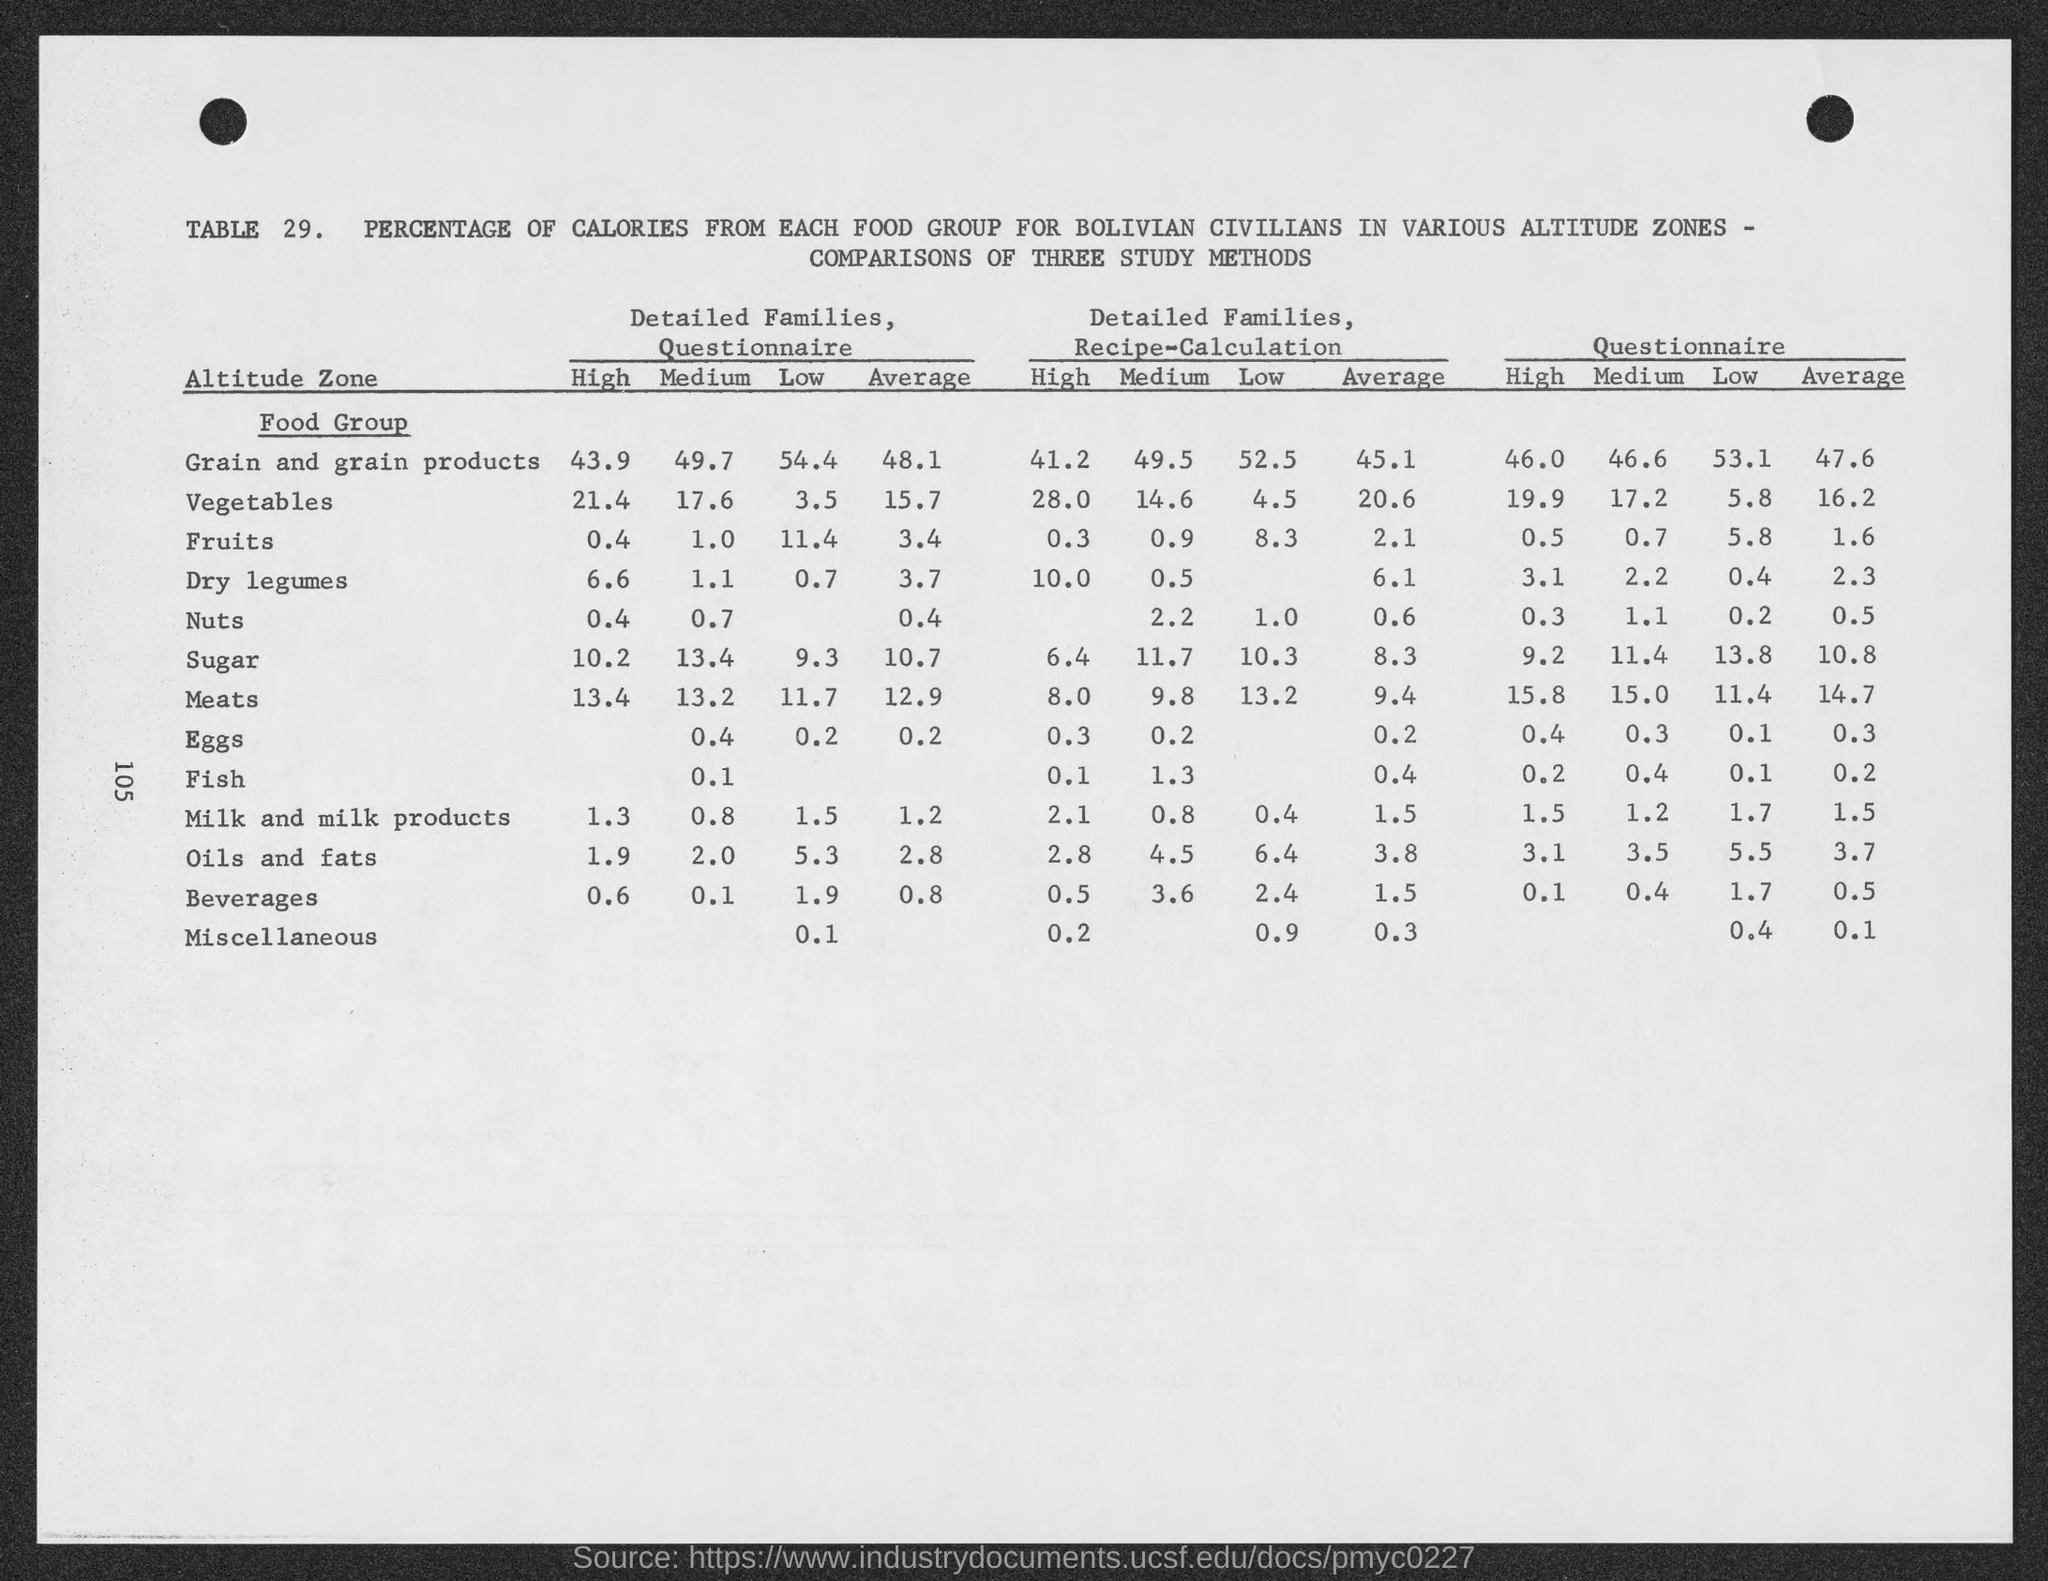Identify some key points in this picture. The "High" rating for detailed families in the questionnaire for fruits is 0.4. The "High" value for the Detailed Families, Questionnaire for Grain and Grain Products is 43.9. The "High" value for detailed families, questionnaire for meat is 13.4. The "High" value for the Detailed Families, Questionnaire for Dry Legumes is 6.6. The "High" for Detailed Families, Questionnaire for sugar is 10.2. 